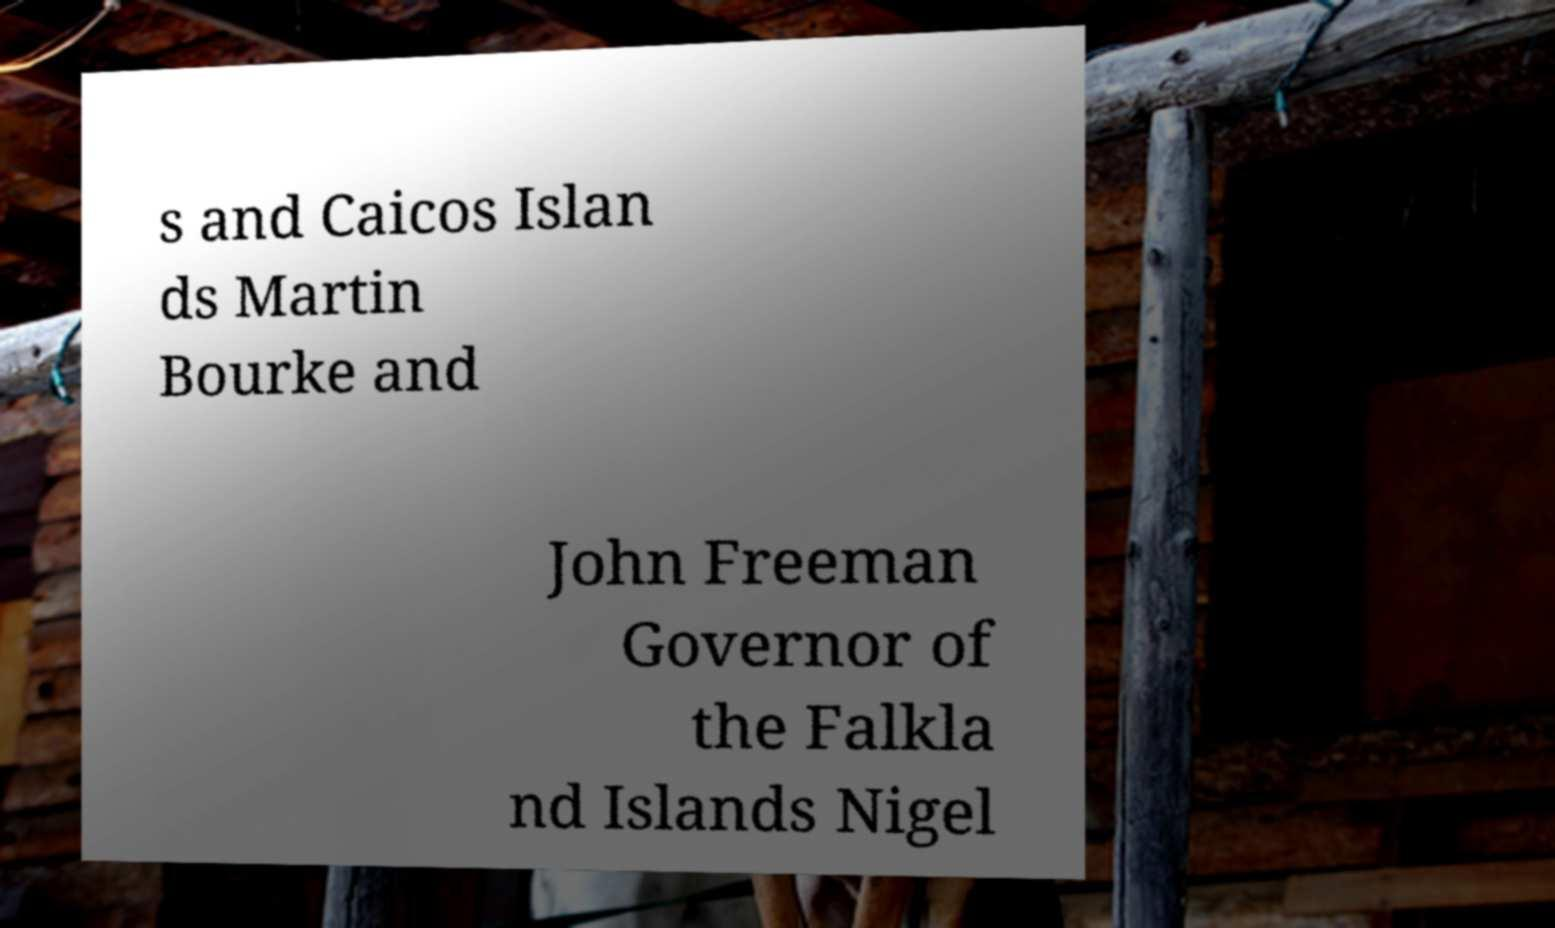Could you assist in decoding the text presented in this image and type it out clearly? s and Caicos Islan ds Martin Bourke and John Freeman Governor of the Falkla nd Islands Nigel 